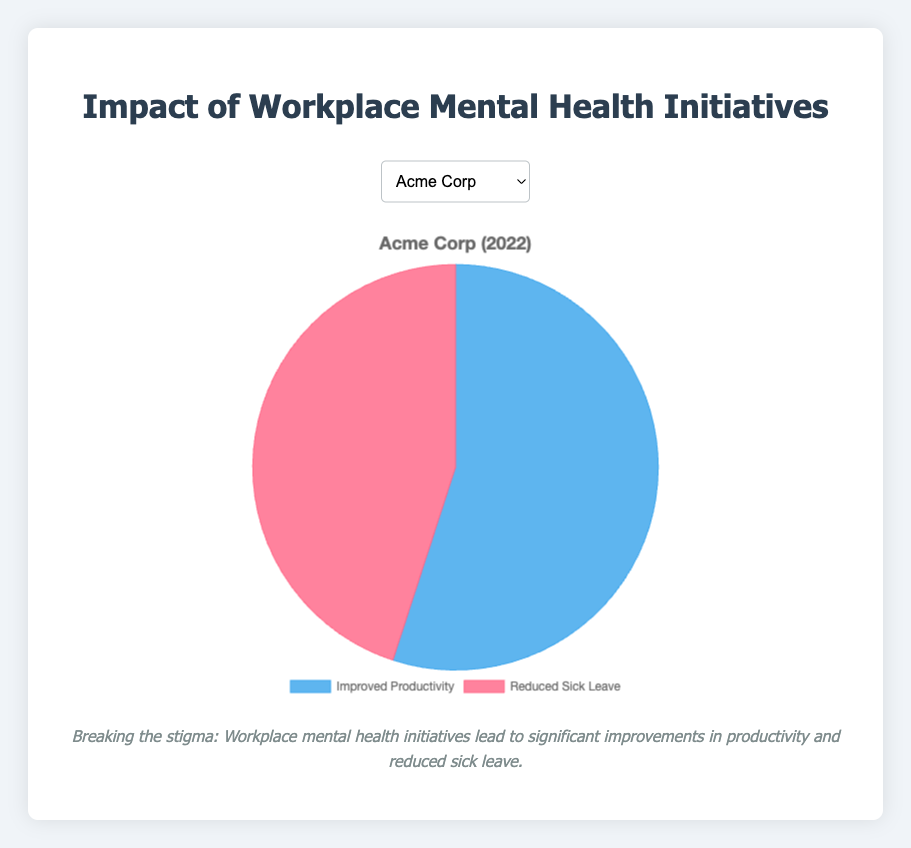What percentage of Acme Corp’s improved productivity can be attributed to workplace mental health initiatives in 2022? The pie chart will show that 55% of Acme Corp's productivity improvement is due to workplace mental health initiatives for the year 2022.
Answer: 55% Is the percentage of reduced sick leave higher in TechnoSoft Ltd or HealthFirst Inc for the year 2022? From the pie chart, compare the percentage figures for reduced sick leave for both TechnoSoft Ltd (2022) and HealthFirst Inc (2021). TechnoSoft Ltd has a reduced sick leave percentage of 40%, whereas HealthFirst Inc has 35%.
Answer: TechnoSoft Ltd What is the difference in the percentage of improved productivity between GreenWorks and Acme Corp for 2021? Compare the improved productivity percentages of GreenWorks (58%) and Acme Corp (55%) from the pie chart for the year 2021. Calculate the difference as 58% - 55%.
Answer: 3% Which visual segment color represents improved productivity in the charts? When looking at the pie chart, improved productivity is shown by the blue segment.
Answer: Blue What is the combined percentage of improved productivity for TechnoSoft Ltd and HealthFirst Inc? Add the improved productivity percentages for TechnoSoft Ltd (60%) and HealthFirst Inc (65%) as shown in the chart. The sum is 60% + 65%.
Answer: 125% Which company has the least percentage of reduced sick leave in the data provided? The pie chart shows reduced sick leave percentages for each company. Among them, HealthFirst Inc has the least reduced sick leave percentage at 35%.
Answer: HealthFirst Inc How much higher is the percentage of improved productivity for HealthFirst Inc compared to TechnoSoft Ltd? Compare the improved productivity of HealthFirst Inc (65%) to TechnoSoft Ltd (60%) and calculate the difference: 65% - 60%.
Answer: 5% For GreenWorks, what proportion of impact on workplace mental health initiatives is not attributed to improved productivity? The chart shows the impact of 58% for improved productivity, so the remaining proportion is 100% - 58% for GreenWorks.
Answer: 42% If you were to average the percentage impact on improved productivity across all companies, what would it be? To find the average, sum up the improved productivity percentages for all companies: 55% (Acme Corp) + 60% (TechnoSoft Ltd) + 65% (HealthFirst Inc) + 58% (GreenWorks) = 238%. Then divide by the number of companies: 238% / 4.
Answer: 59.5% Which company observed the greatest effect from workplace mental health initiatives on improving productivity in the given data? From the data shown in the pie chart, HealthFirst Inc has the highest percentage (65%) of improved productivity due to workplace mental health initiatives for 2021.
Answer: HealthFirst Inc 